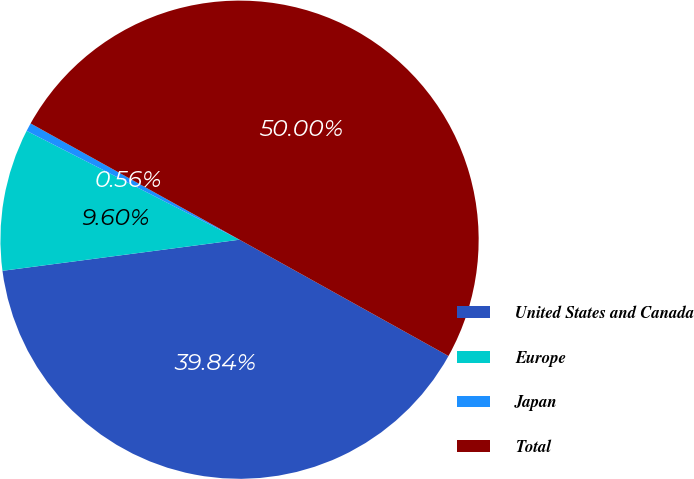<chart> <loc_0><loc_0><loc_500><loc_500><pie_chart><fcel>United States and Canada<fcel>Europe<fcel>Japan<fcel>Total<nl><fcel>39.84%<fcel>9.6%<fcel>0.56%<fcel>50.0%<nl></chart> 